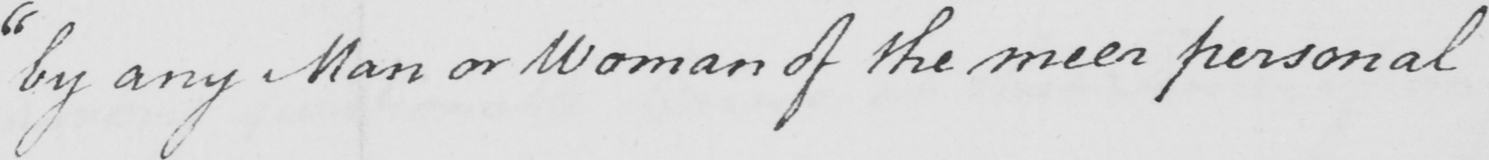Can you tell me what this handwritten text says? " by any Man or Woman of the meer personal 